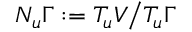Convert formula to latex. <formula><loc_0><loc_0><loc_500><loc_500>N _ { u } \Gamma \colon = T _ { u } V \Big / T _ { u } \Gamma</formula> 